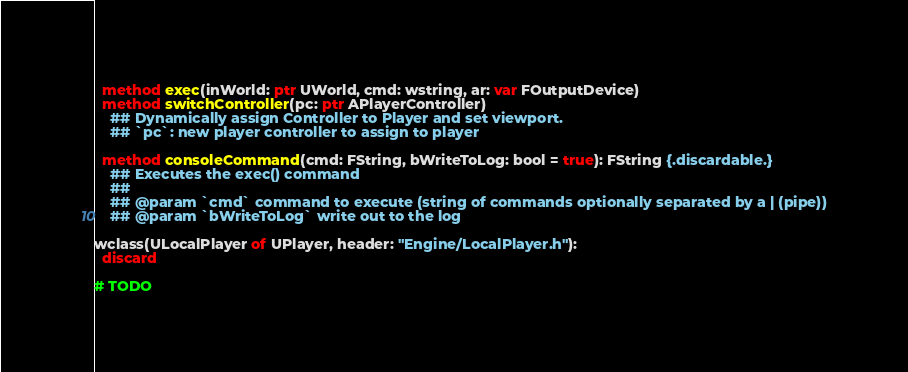<code> <loc_0><loc_0><loc_500><loc_500><_Nim_>
  method exec(inWorld: ptr UWorld, cmd: wstring, ar: var FOutputDevice)
  method switchController(pc: ptr APlayerController)
    ## Dynamically assign Controller to Player and set viewport.
    ## `pc`: new player controller to assign to player

  method consoleCommand(cmd: FString, bWriteToLog: bool = true): FString {.discardable.}
    ## Executes the exec() command
    ##
    ## @param `cmd` command to execute (string of commands optionally separated by a | (pipe))
    ## @param `bWriteToLog` write out to the log

wclass(ULocalPlayer of UPlayer, header: "Engine/LocalPlayer.h"):
  discard

# TODO</code> 